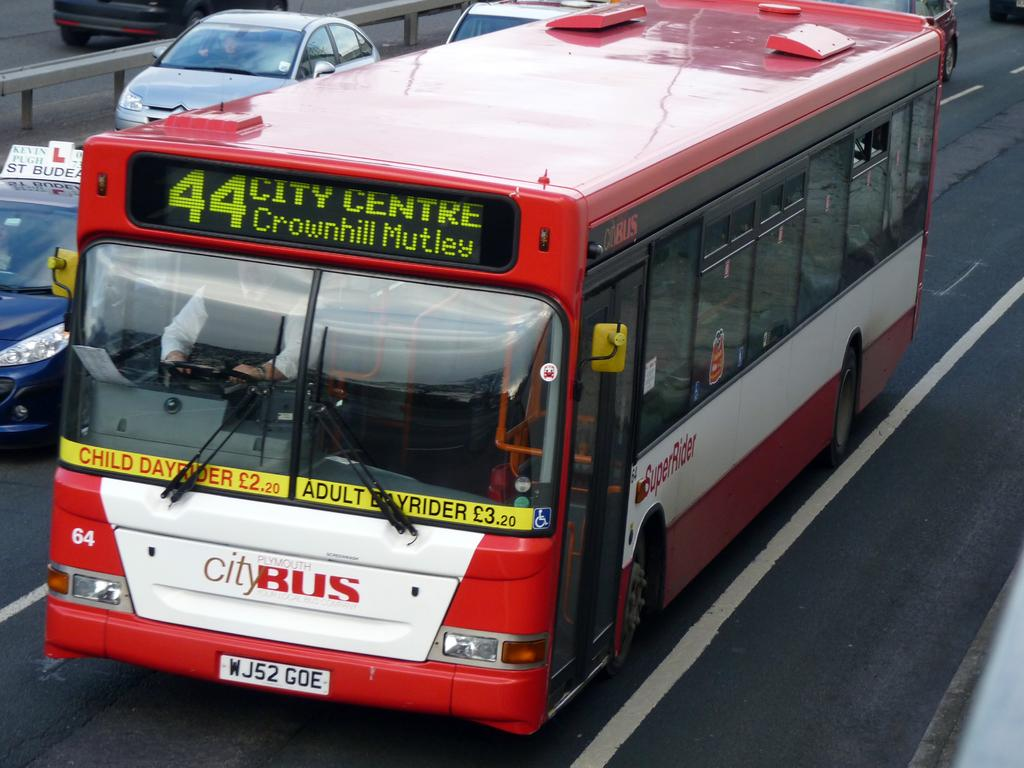What is the main subject in the foreground of the image? There is a red color bus in the foreground of the image. What is the bus doing in the image? The bus is moving on the road. What can be seen in the background of the image? There are vehicles and a divider in the background of the image. How many trees are growing on the roof of the bus in the image? There are no trees growing on the roof of the bus in the image. What type of net is being used by the bus to catch pedestrians? There is no net present in the image, and the bus is not attempting to catch pedestrians. 